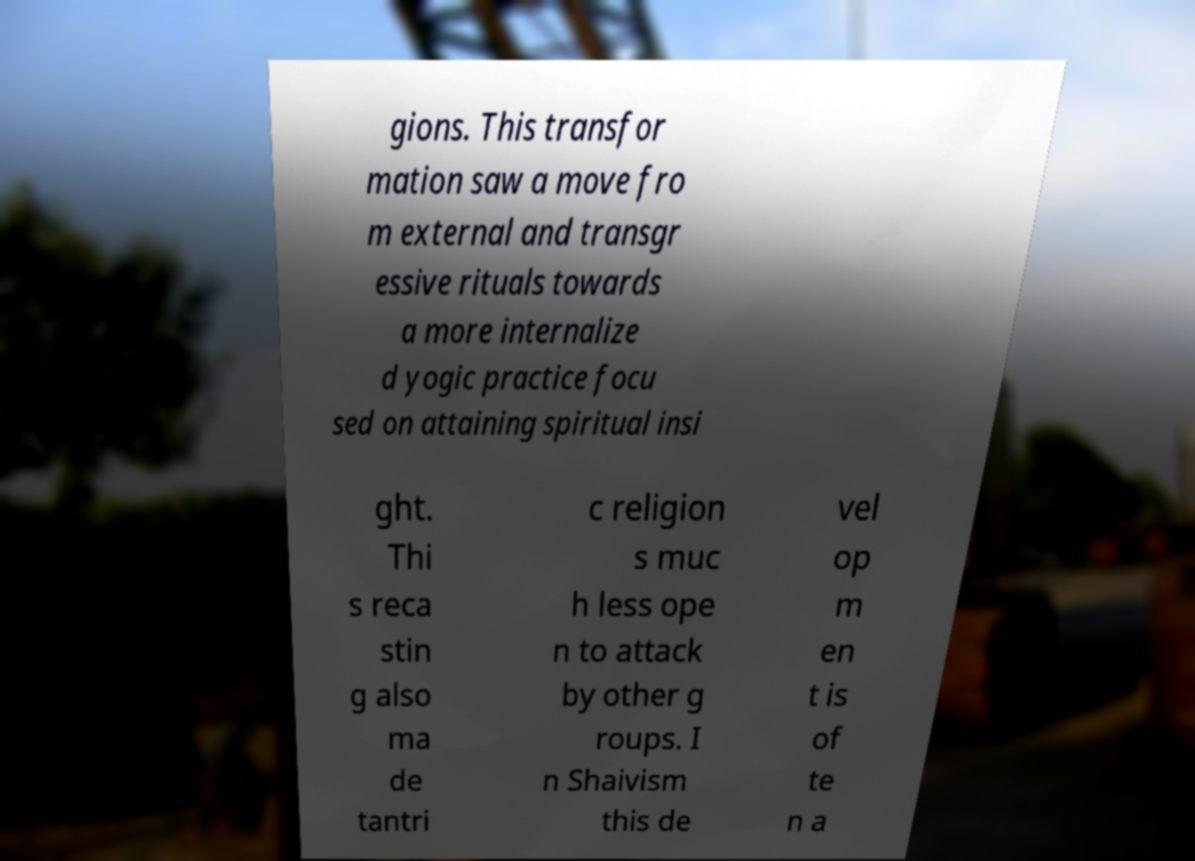I need the written content from this picture converted into text. Can you do that? gions. This transfor mation saw a move fro m external and transgr essive rituals towards a more internalize d yogic practice focu sed on attaining spiritual insi ght. Thi s reca stin g also ma de tantri c religion s muc h less ope n to attack by other g roups. I n Shaivism this de vel op m en t is of te n a 